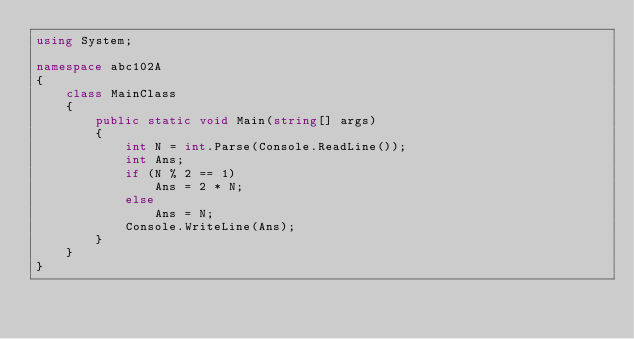<code> <loc_0><loc_0><loc_500><loc_500><_C#_>using System;

namespace abc102A
{
    class MainClass
    {
        public static void Main(string[] args)
        {
            int N = int.Parse(Console.ReadLine());
            int Ans;
            if (N % 2 == 1)
                Ans = 2 * N;
            else
                Ans = N;
            Console.WriteLine(Ans);
        }
    }
}
</code> 